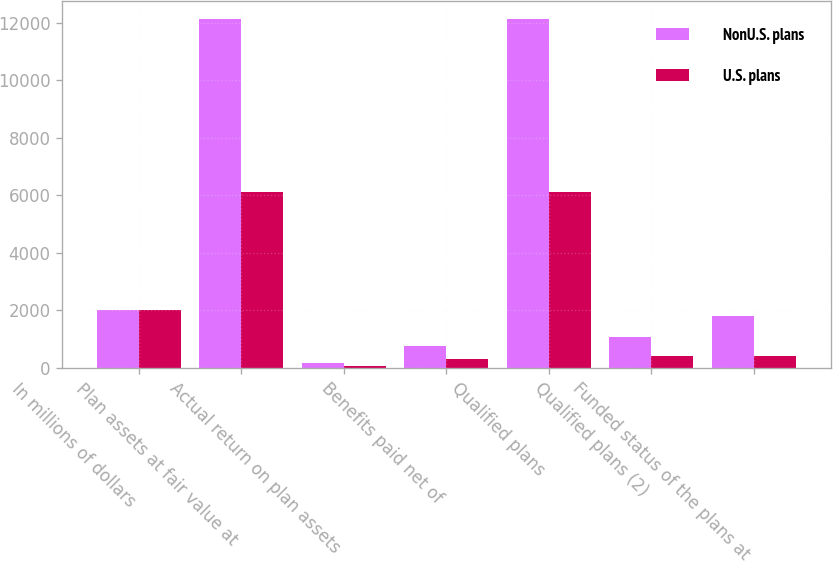<chart> <loc_0><loc_0><loc_500><loc_500><stacked_bar_chart><ecel><fcel>In millions of dollars<fcel>Plan assets at fair value at<fcel>Actual return on plan assets<fcel>Benefits paid net of<fcel>Qualified plans<fcel>Qualified plans (2)<fcel>Funded status of the plans at<nl><fcel>NonU.S. plans<fcel>2015<fcel>12137<fcel>183<fcel>751<fcel>12137<fcel>1094<fcel>1806<nl><fcel>U.S. plans<fcel>2015<fcel>6104<fcel>56<fcel>299<fcel>6104<fcel>430<fcel>430<nl></chart> 